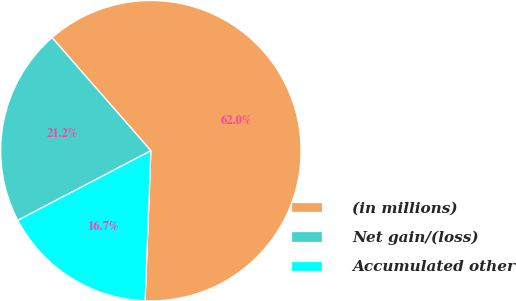Convert chart to OTSL. <chart><loc_0><loc_0><loc_500><loc_500><pie_chart><fcel>(in millions)<fcel>Net gain/(loss)<fcel>Accumulated other<nl><fcel>62.04%<fcel>21.24%<fcel>16.71%<nl></chart> 